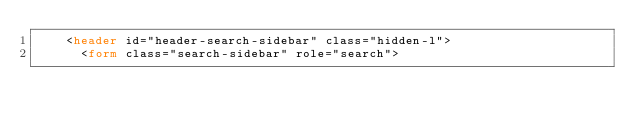Convert code to text. <code><loc_0><loc_0><loc_500><loc_500><_HTML_>    <header id="header-search-sidebar" class="hidden-l">
      <form class="search-sidebar" role="search"></code> 